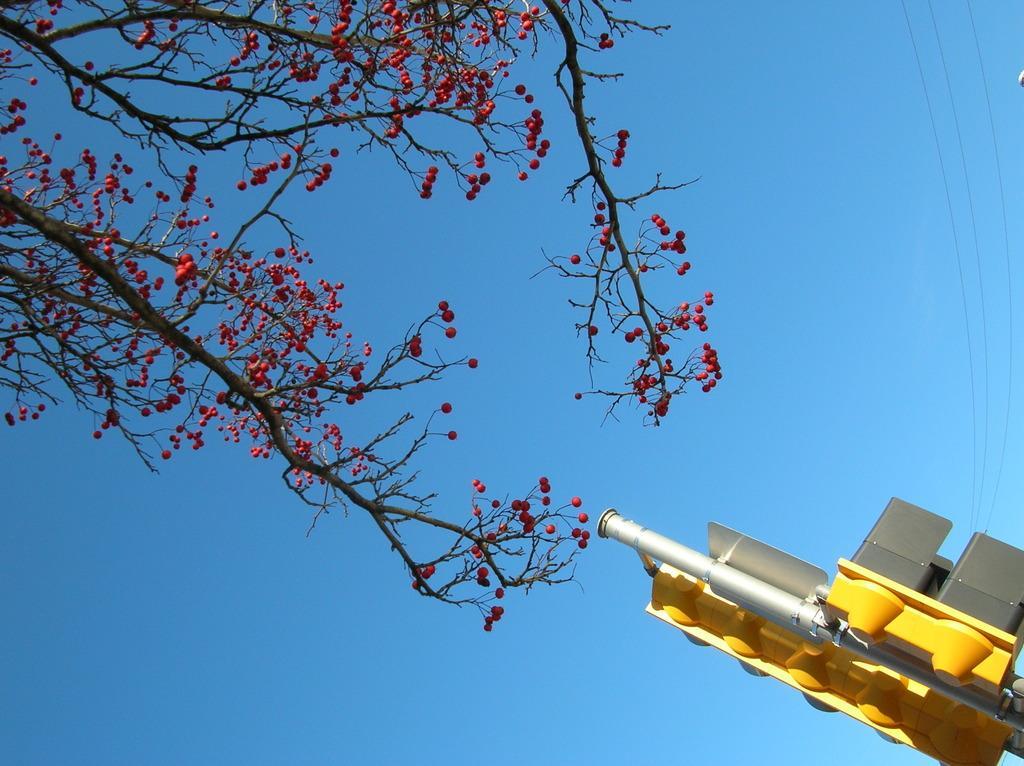Please provide a concise description of this image. In this picture there is a red color flower tree in the front. Beside there is a yellow color traffic pole. On the top there is a blue sky. 